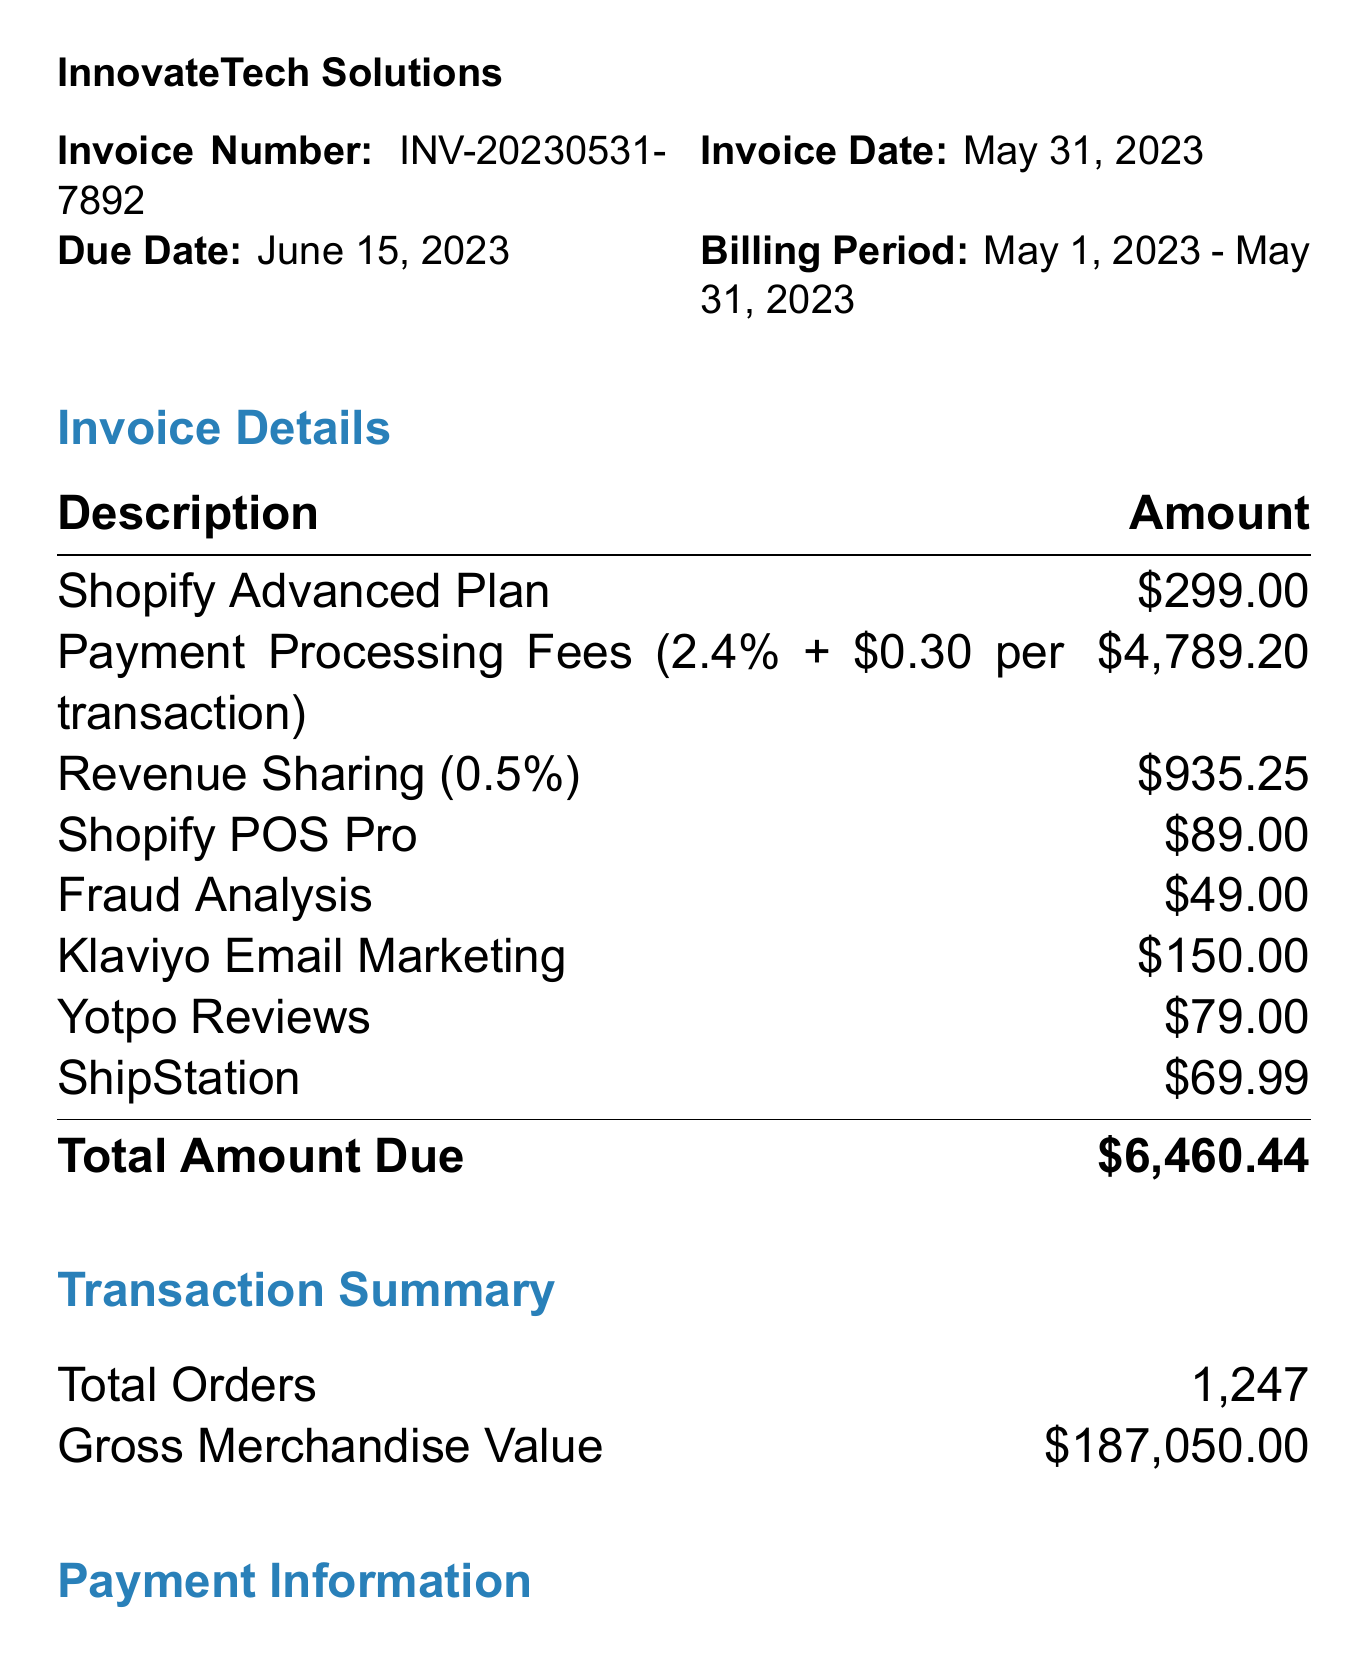What is the invoice number? The invoice number is specified clearly in the document, which is INV-20230531-7892.
Answer: INV-20230531-7892 What is the invoice date? The invoice date is the date when the invoice was issued, mentioned as May 31, 2023.
Answer: May 31, 2023 What is the total amount due? The total amount due is located at the bottom of the invoice details, which is $6,460.44.
Answer: $6,460.44 How many total orders were processed? The total orders are recorded in the transaction summary, which states there were 1,247 orders.
Answer: 1,247 What is the revenue sharing rate? The revenue sharing rate is given in the revenue sharing section, which specifies it as 0.5%.
Answer: 0.5% Who is the account manager? The account manager's name is listed in the contact information section, which identifies Sarah Johnson.
Answer: Sarah Johnson What additional service has the highest fee? Among the listed additional services, Shopify POS Pro has the highest fee of $89.00.
Answer: Shopify POS Pro When is the payment due? The due date for payment is clearly indicated as June 15, 2023.
Answer: June 15, 2023 What payment method was used? The payment method is specified in the payment information section, which states it is a Credit Card.
Answer: Credit Card 